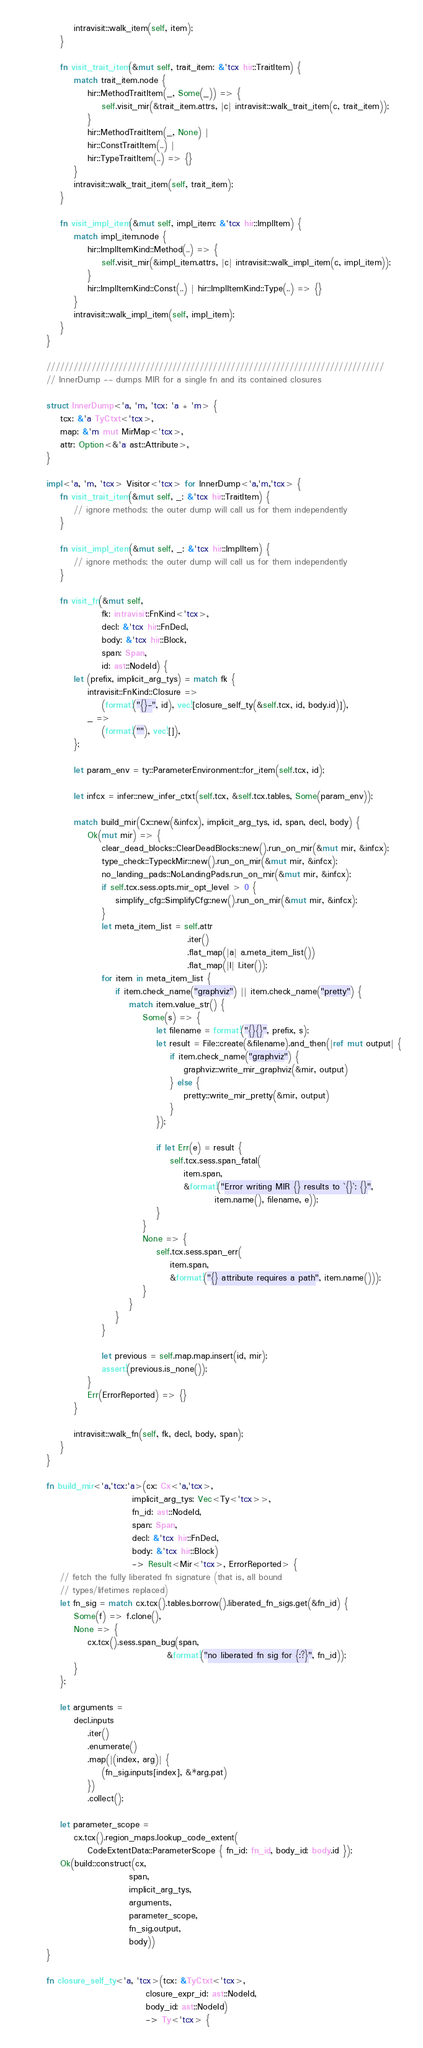Convert code to text. <code><loc_0><loc_0><loc_500><loc_500><_Rust_>        intravisit::walk_item(self, item);
    }

    fn visit_trait_item(&mut self, trait_item: &'tcx hir::TraitItem) {
        match trait_item.node {
            hir::MethodTraitItem(_, Some(_)) => {
                self.visit_mir(&trait_item.attrs, |c| intravisit::walk_trait_item(c, trait_item));
            }
            hir::MethodTraitItem(_, None) |
            hir::ConstTraitItem(..) |
            hir::TypeTraitItem(..) => {}
        }
        intravisit::walk_trait_item(self, trait_item);
    }

    fn visit_impl_item(&mut self, impl_item: &'tcx hir::ImplItem) {
        match impl_item.node {
            hir::ImplItemKind::Method(..) => {
                self.visit_mir(&impl_item.attrs, |c| intravisit::walk_impl_item(c, impl_item));
            }
            hir::ImplItemKind::Const(..) | hir::ImplItemKind::Type(..) => {}
        }
        intravisit::walk_impl_item(self, impl_item);
    }
}

///////////////////////////////////////////////////////////////////////////
// InnerDump -- dumps MIR for a single fn and its contained closures

struct InnerDump<'a, 'm, 'tcx: 'a + 'm> {
    tcx: &'a TyCtxt<'tcx>,
    map: &'m mut MirMap<'tcx>,
    attr: Option<&'a ast::Attribute>,
}

impl<'a, 'm, 'tcx> Visitor<'tcx> for InnerDump<'a,'m,'tcx> {
    fn visit_trait_item(&mut self, _: &'tcx hir::TraitItem) {
        // ignore methods; the outer dump will call us for them independently
    }

    fn visit_impl_item(&mut self, _: &'tcx hir::ImplItem) {
        // ignore methods; the outer dump will call us for them independently
    }

    fn visit_fn(&mut self,
                fk: intravisit::FnKind<'tcx>,
                decl: &'tcx hir::FnDecl,
                body: &'tcx hir::Block,
                span: Span,
                id: ast::NodeId) {
        let (prefix, implicit_arg_tys) = match fk {
            intravisit::FnKind::Closure =>
                (format!("{}-", id), vec![closure_self_ty(&self.tcx, id, body.id)]),
            _ =>
                (format!(""), vec![]),
        };

        let param_env = ty::ParameterEnvironment::for_item(self.tcx, id);

        let infcx = infer::new_infer_ctxt(self.tcx, &self.tcx.tables, Some(param_env));

        match build_mir(Cx::new(&infcx), implicit_arg_tys, id, span, decl, body) {
            Ok(mut mir) => {
                clear_dead_blocks::ClearDeadBlocks::new().run_on_mir(&mut mir, &infcx);
                type_check::TypeckMir::new().run_on_mir(&mut mir, &infcx);
                no_landing_pads::NoLandingPads.run_on_mir(&mut mir, &infcx);
                if self.tcx.sess.opts.mir_opt_level > 0 {
                    simplify_cfg::SimplifyCfg::new().run_on_mir(&mut mir, &infcx);
                }
                let meta_item_list = self.attr
                                         .iter()
                                         .flat_map(|a| a.meta_item_list())
                                         .flat_map(|l| l.iter());
                for item in meta_item_list {
                    if item.check_name("graphviz") || item.check_name("pretty") {
                        match item.value_str() {
                            Some(s) => {
                                let filename = format!("{}{}", prefix, s);
                                let result = File::create(&filename).and_then(|ref mut output| {
                                    if item.check_name("graphviz") {
                                        graphviz::write_mir_graphviz(&mir, output)
                                    } else {
                                        pretty::write_mir_pretty(&mir, output)
                                    }
                                });

                                if let Err(e) = result {
                                    self.tcx.sess.span_fatal(
                                        item.span,
                                        &format!("Error writing MIR {} results to `{}`: {}",
                                                 item.name(), filename, e));
                                }
                            }
                            None => {
                                self.tcx.sess.span_err(
                                    item.span,
                                    &format!("{} attribute requires a path", item.name()));
                            }
                        }
                    }
                }

                let previous = self.map.map.insert(id, mir);
                assert!(previous.is_none());
            }
            Err(ErrorReported) => {}
        }

        intravisit::walk_fn(self, fk, decl, body, span);
    }
}

fn build_mir<'a,'tcx:'a>(cx: Cx<'a,'tcx>,
                         implicit_arg_tys: Vec<Ty<'tcx>>,
                         fn_id: ast::NodeId,
                         span: Span,
                         decl: &'tcx hir::FnDecl,
                         body: &'tcx hir::Block)
                         -> Result<Mir<'tcx>, ErrorReported> {
    // fetch the fully liberated fn signature (that is, all bound
    // types/lifetimes replaced)
    let fn_sig = match cx.tcx().tables.borrow().liberated_fn_sigs.get(&fn_id) {
        Some(f) => f.clone(),
        None => {
            cx.tcx().sess.span_bug(span,
                                   &format!("no liberated fn sig for {:?}", fn_id));
        }
    };

    let arguments =
        decl.inputs
            .iter()
            .enumerate()
            .map(|(index, arg)| {
                (fn_sig.inputs[index], &*arg.pat)
            })
            .collect();

    let parameter_scope =
        cx.tcx().region_maps.lookup_code_extent(
            CodeExtentData::ParameterScope { fn_id: fn_id, body_id: body.id });
    Ok(build::construct(cx,
                        span,
                        implicit_arg_tys,
                        arguments,
                        parameter_scope,
                        fn_sig.output,
                        body))
}

fn closure_self_ty<'a, 'tcx>(tcx: &TyCtxt<'tcx>,
                             closure_expr_id: ast::NodeId,
                             body_id: ast::NodeId)
                             -> Ty<'tcx> {</code> 